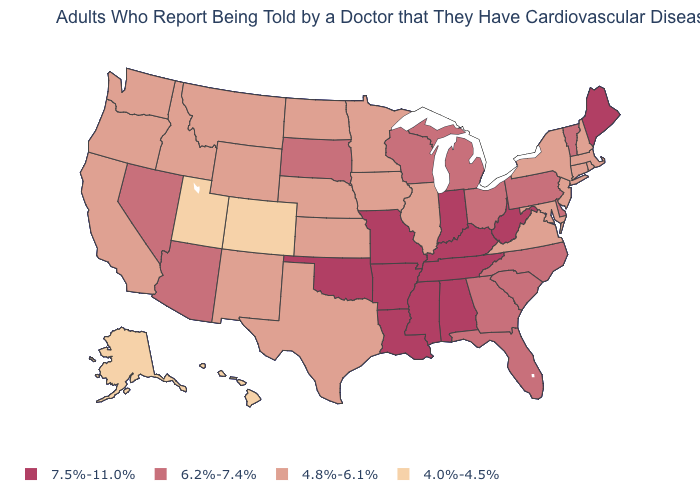How many symbols are there in the legend?
Give a very brief answer. 4. Which states have the lowest value in the USA?
Give a very brief answer. Alaska, Colorado, Hawaii, Utah. Is the legend a continuous bar?
Be succinct. No. What is the highest value in the USA?
Concise answer only. 7.5%-11.0%. How many symbols are there in the legend?
Quick response, please. 4. Does the map have missing data?
Give a very brief answer. No. What is the value of Maryland?
Write a very short answer. 4.8%-6.1%. What is the lowest value in the South?
Concise answer only. 4.8%-6.1%. What is the value of Hawaii?
Quick response, please. 4.0%-4.5%. Name the states that have a value in the range 6.2%-7.4%?
Answer briefly. Arizona, Delaware, Florida, Georgia, Michigan, Nevada, North Carolina, Ohio, Pennsylvania, South Carolina, South Dakota, Vermont, Wisconsin. Does Mississippi have a higher value than Arkansas?
Concise answer only. No. Does the map have missing data?
Be succinct. No. What is the value of Virginia?
Short answer required. 4.8%-6.1%. Is the legend a continuous bar?
Answer briefly. No. Among the states that border Michigan , does Wisconsin have the lowest value?
Answer briefly. Yes. 